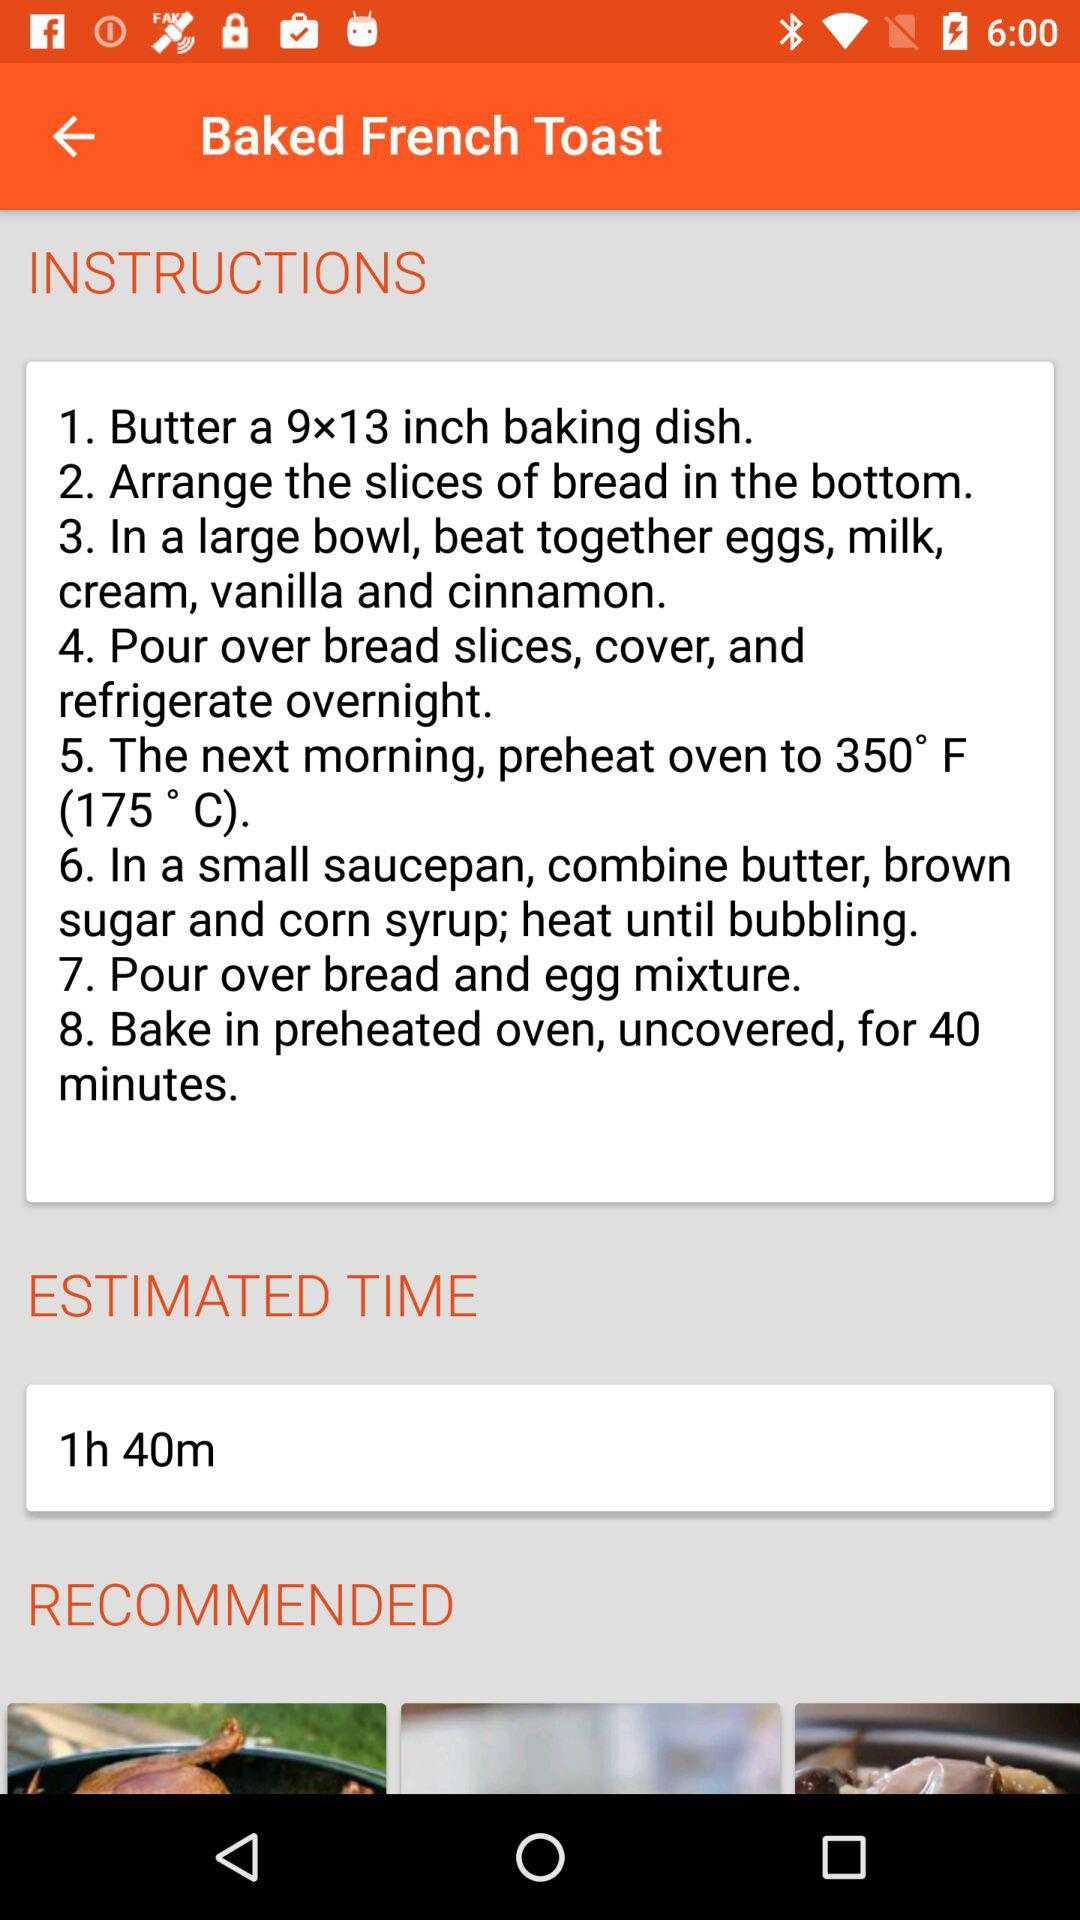How many steps are there in the recipe?
Answer the question using a single word or phrase. 8 